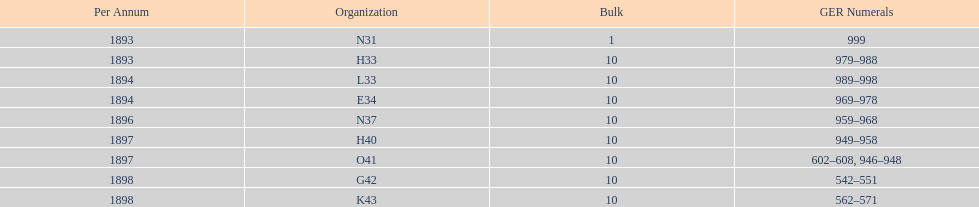What is the total number of locomotives made during this time? 81. 